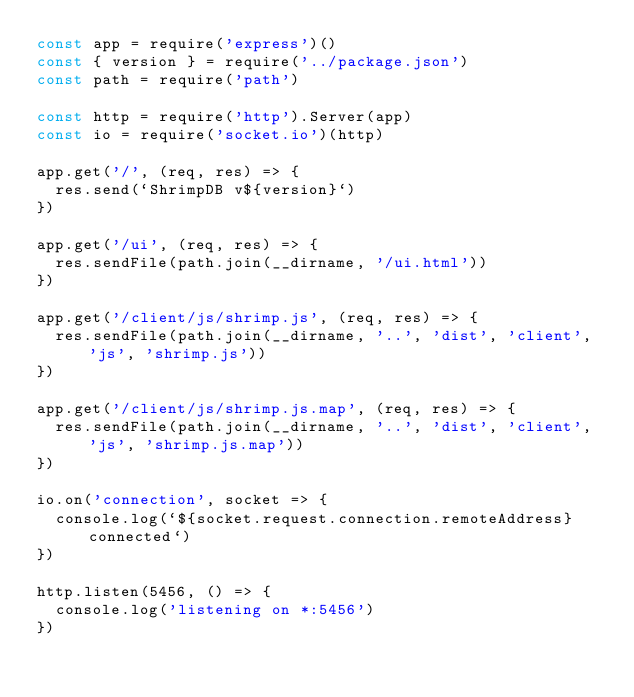Convert code to text. <code><loc_0><loc_0><loc_500><loc_500><_JavaScript_>const app = require('express')()
const { version } = require('../package.json')
const path = require('path')

const http = require('http').Server(app)
const io = require('socket.io')(http)

app.get('/', (req, res) => {
  res.send(`ShrimpDB v${version}`)
})

app.get('/ui', (req, res) => {
  res.sendFile(path.join(__dirname, '/ui.html'))
})

app.get('/client/js/shrimp.js', (req, res) => {
  res.sendFile(path.join(__dirname, '..', 'dist', 'client', 'js', 'shrimp.js'))
})

app.get('/client/js/shrimp.js.map', (req, res) => {
  res.sendFile(path.join(__dirname, '..', 'dist', 'client', 'js', 'shrimp.js.map'))
})

io.on('connection', socket => {
  console.log(`${socket.request.connection.remoteAddress} connected`)
})

http.listen(5456, () => {
  console.log('listening on *:5456')
})
</code> 